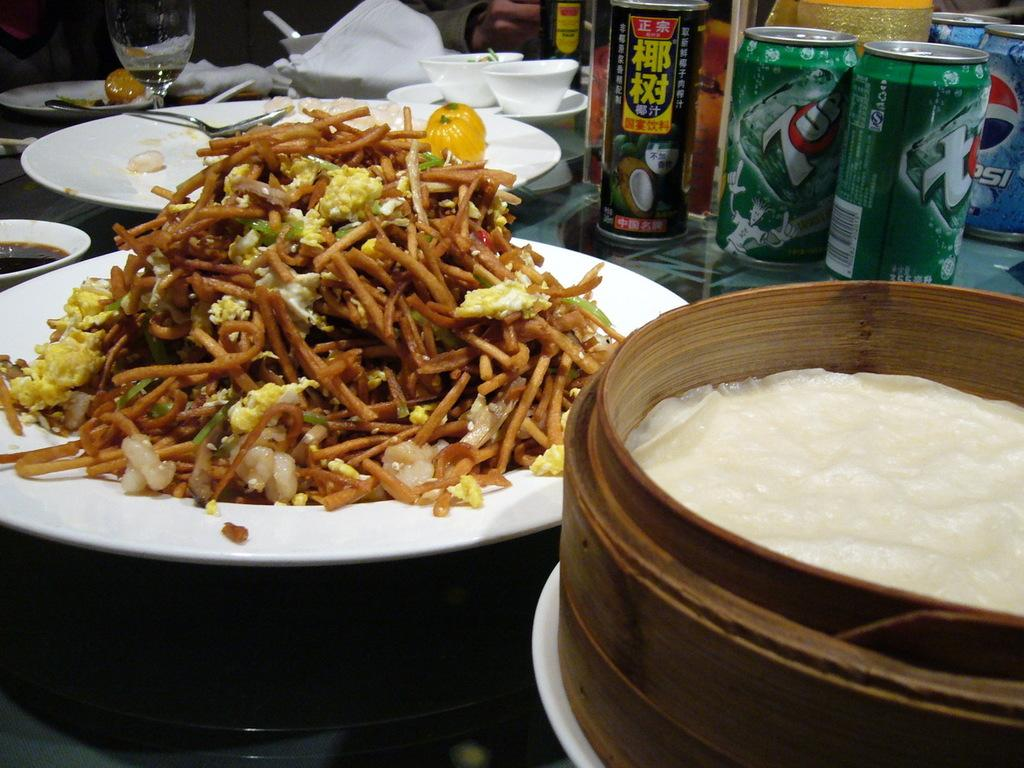What is placed on the white plate in the image? There are eatables placed on a white plate in the image. What type of objects are visible in the image? There are tens and glasses in the image. Can you describe any other objects present in the image? Yes, there are other objects present in the image. What type of chain can be seen connecting the glasses in the image? There is no chain connecting the glasses in the image. 